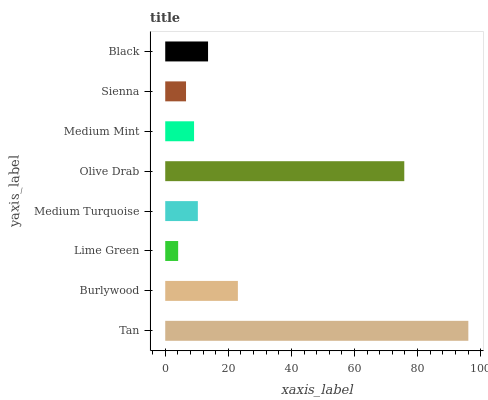Is Lime Green the minimum?
Answer yes or no. Yes. Is Tan the maximum?
Answer yes or no. Yes. Is Burlywood the minimum?
Answer yes or no. No. Is Burlywood the maximum?
Answer yes or no. No. Is Tan greater than Burlywood?
Answer yes or no. Yes. Is Burlywood less than Tan?
Answer yes or no. Yes. Is Burlywood greater than Tan?
Answer yes or no. No. Is Tan less than Burlywood?
Answer yes or no. No. Is Black the high median?
Answer yes or no. Yes. Is Medium Turquoise the low median?
Answer yes or no. Yes. Is Medium Turquoise the high median?
Answer yes or no. No. Is Black the low median?
Answer yes or no. No. 